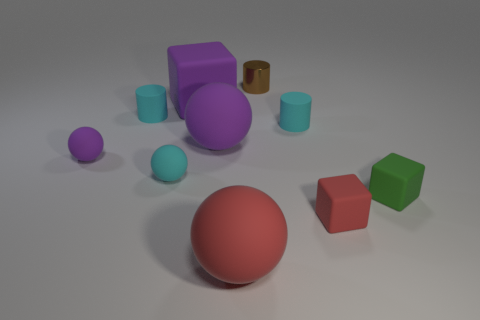Subtract 2 spheres. How many spheres are left? 2 Subtract all yellow spheres. Subtract all gray blocks. How many spheres are left? 4 Subtract all spheres. How many objects are left? 6 Subtract all large purple rubber balls. Subtract all small cyan matte spheres. How many objects are left? 8 Add 1 tiny brown metallic objects. How many tiny brown metallic objects are left? 2 Add 6 small yellow matte cylinders. How many small yellow matte cylinders exist? 6 Subtract 1 green cubes. How many objects are left? 9 